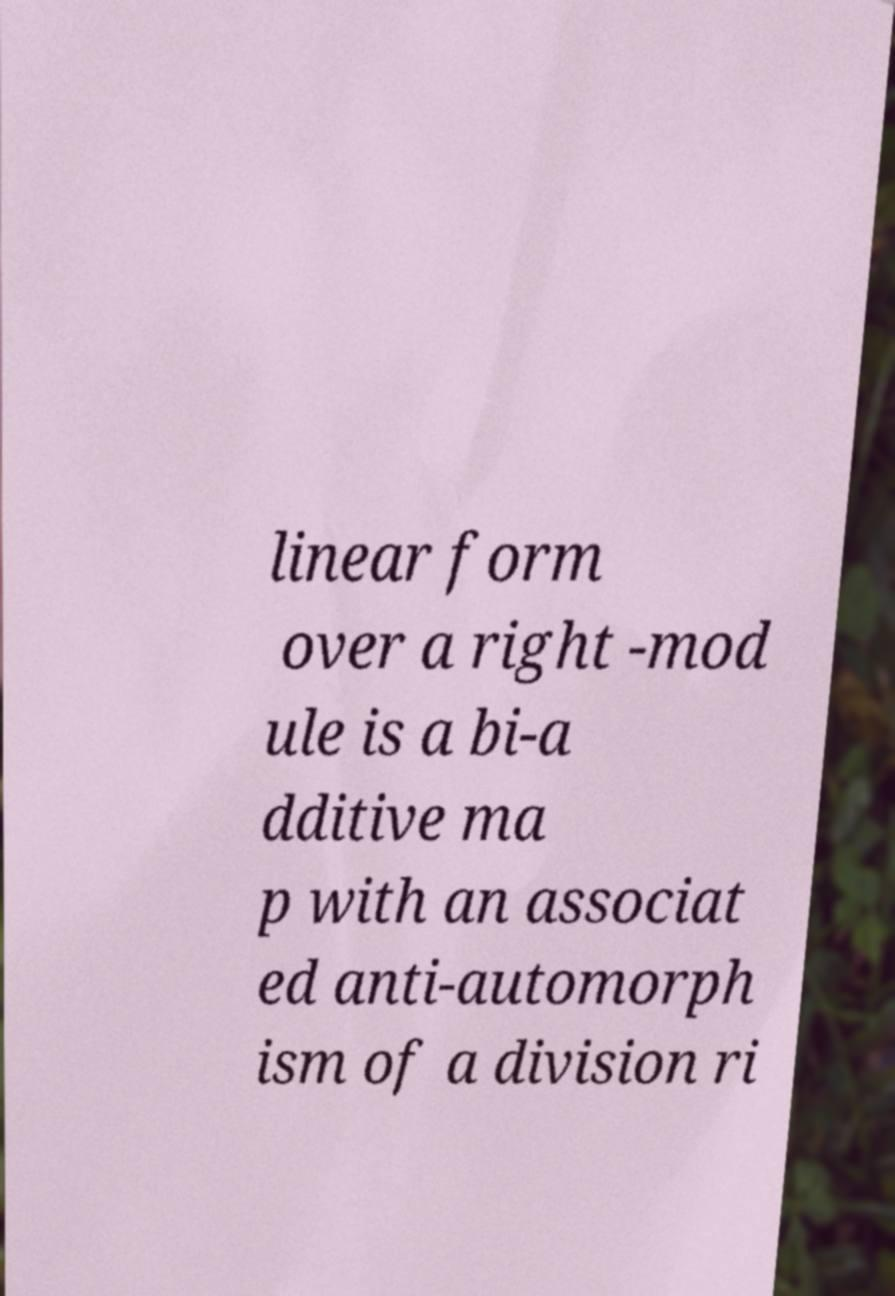Please identify and transcribe the text found in this image. linear form over a right -mod ule is a bi-a dditive ma p with an associat ed anti-automorph ism of a division ri 